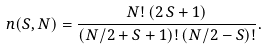<formula> <loc_0><loc_0><loc_500><loc_500>n ( S , N ) = \frac { N ! \, ( 2 \, S + 1 ) } { ( N / 2 + S + 1 ) ! \, ( N / 2 - S ) ! } .</formula> 